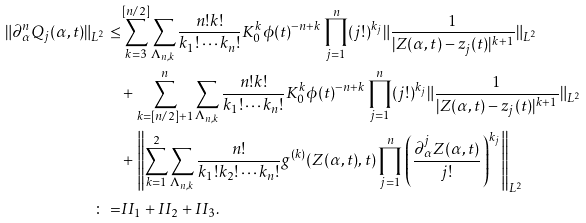<formula> <loc_0><loc_0><loc_500><loc_500>\| \partial _ { \alpha } ^ { n } Q _ { j } ( \alpha , t ) \| _ { L ^ { 2 } } \leq & \sum _ { k = 3 } ^ { [ n / 2 ] } \sum _ { \Lambda _ { n , k } } \frac { n ! k ! } { k _ { 1 } ! \cdots k _ { n } ! } K _ { 0 } ^ { k } \phi ( t ) ^ { - n + k } \prod _ { j = 1 } ^ { n } ( j ! ) ^ { k _ { j } } \| \frac { 1 } { | Z ( \alpha , t ) - z _ { j } ( t ) | ^ { k + 1 } } \| _ { L ^ { 2 } } \\ & + \sum _ { k = [ n / 2 ] + 1 } ^ { n } \sum _ { \Lambda _ { n , k } } \frac { n ! k ! } { k _ { 1 } ! \cdots k _ { n } ! } K _ { 0 } ^ { k } \phi ( t ) ^ { - n + k } \prod _ { j = 1 } ^ { n } ( j ! ) ^ { k _ { j } } \| \frac { 1 } { | Z ( \alpha , t ) - z _ { j } ( t ) | ^ { k + 1 } } \| _ { L ^ { 2 } } \\ & + \left \| \sum _ { k = 1 } ^ { 2 } \sum _ { \Lambda _ { n , k } } \frac { n ! } { k _ { 1 } ! k _ { 2 } ! \cdots k _ { n } ! } g ^ { ( k ) } ( Z ( \alpha , t ) , t ) \prod _ { j = 1 } ^ { n } \left ( \frac { \partial _ { \alpha } ^ { j } Z ( \alpha , t ) } { j ! } \right ) ^ { k _ { j } } \right \| _ { L ^ { 2 } } \\ \colon = & I I _ { 1 } + I I _ { 2 } + I I _ { 3 } .</formula> 